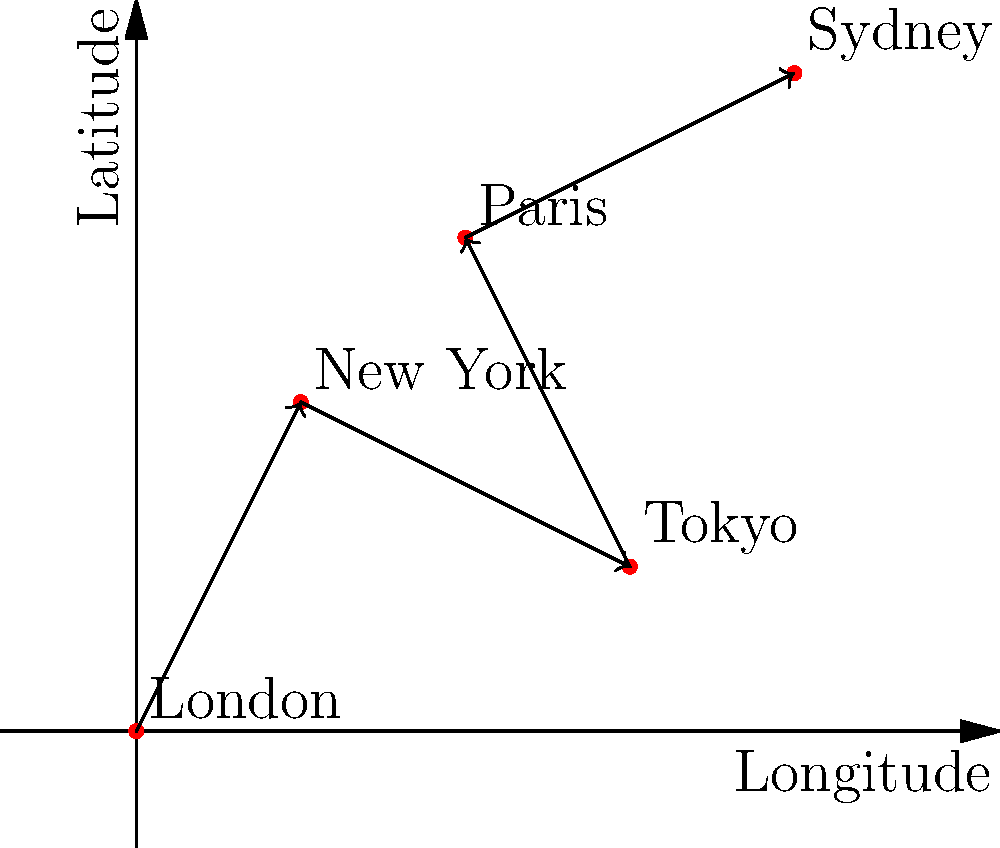Based on the map of your most significant achievements, which city represents the culmination of your career, and how many major milestones preceded it? To answer this question, we need to analyze the map of Jennifer McArton's significant achievements:

1. The map shows five cities: London, New York, Tokyo, Paris, and Sydney.
2. The cities are connected by arrows, indicating the chronological order of achievements.
3. The order of achievements is:
   London → New York → Tokyo → Paris → Sydney
4. Sydney is the last city in the sequence, representing the culmination of the career.
5. To count the major milestones preceding Sydney:
   a. London: 1st milestone
   b. New York: 2nd milestone
   c. Tokyo: 3rd milestone
   d. Paris: 4th milestone
6. There are 4 major milestones before reaching Sydney.

Therefore, Sydney represents the culmination of Jennifer McArton's career, with 4 major milestones preceding it.
Answer: Sydney; 4 